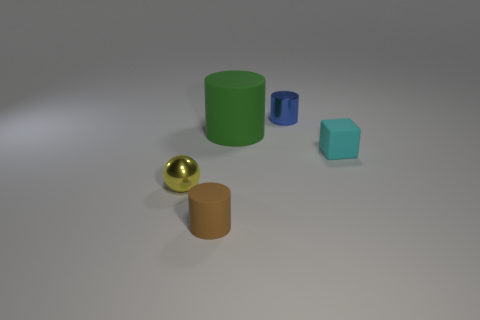Does the cylinder in front of the metallic ball have the same material as the cylinder to the right of the green cylinder?
Your response must be concise. No. How many objects are either cylinders that are in front of the cube or brown cylinders that are in front of the yellow shiny sphere?
Make the answer very short. 1. Is there anything else that is the same shape as the small brown matte object?
Provide a short and direct response. Yes. What number of blue metal blocks are there?
Offer a very short reply. 0. Is there a blue object of the same size as the metal cylinder?
Give a very brief answer. No. Does the tiny brown cylinder have the same material as the small object behind the big green thing?
Make the answer very short. No. What is the material of the cylinder to the left of the big green matte cylinder?
Offer a very short reply. Rubber. What is the size of the yellow object?
Your answer should be compact. Small. There is a cylinder that is in front of the yellow shiny ball; is its size the same as the matte cylinder that is behind the yellow metallic ball?
Your answer should be compact. No. What size is the blue metallic thing that is the same shape as the green thing?
Give a very brief answer. Small. 